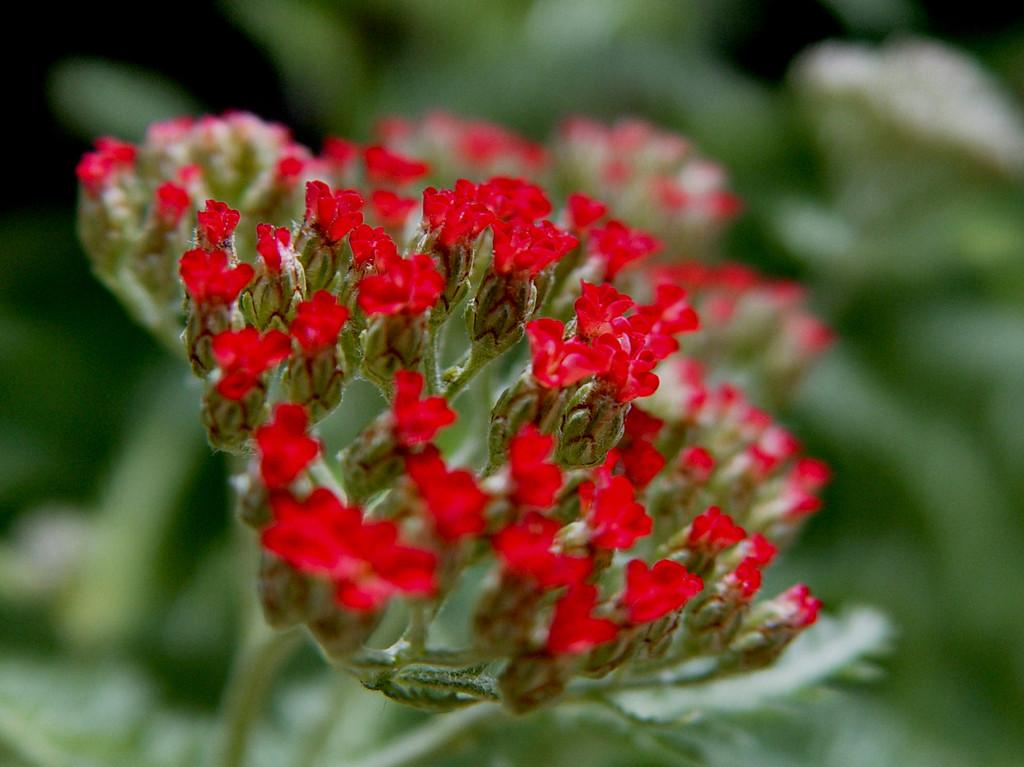What type of living organisms can be seen in the image? Plants can be seen in the image. What specific feature of the plants is visible in the image? The plants have flowers. Is there a spy hiding among the plants in the image? There is no indication of a spy or any person in the image; it only features plants with flowers. 